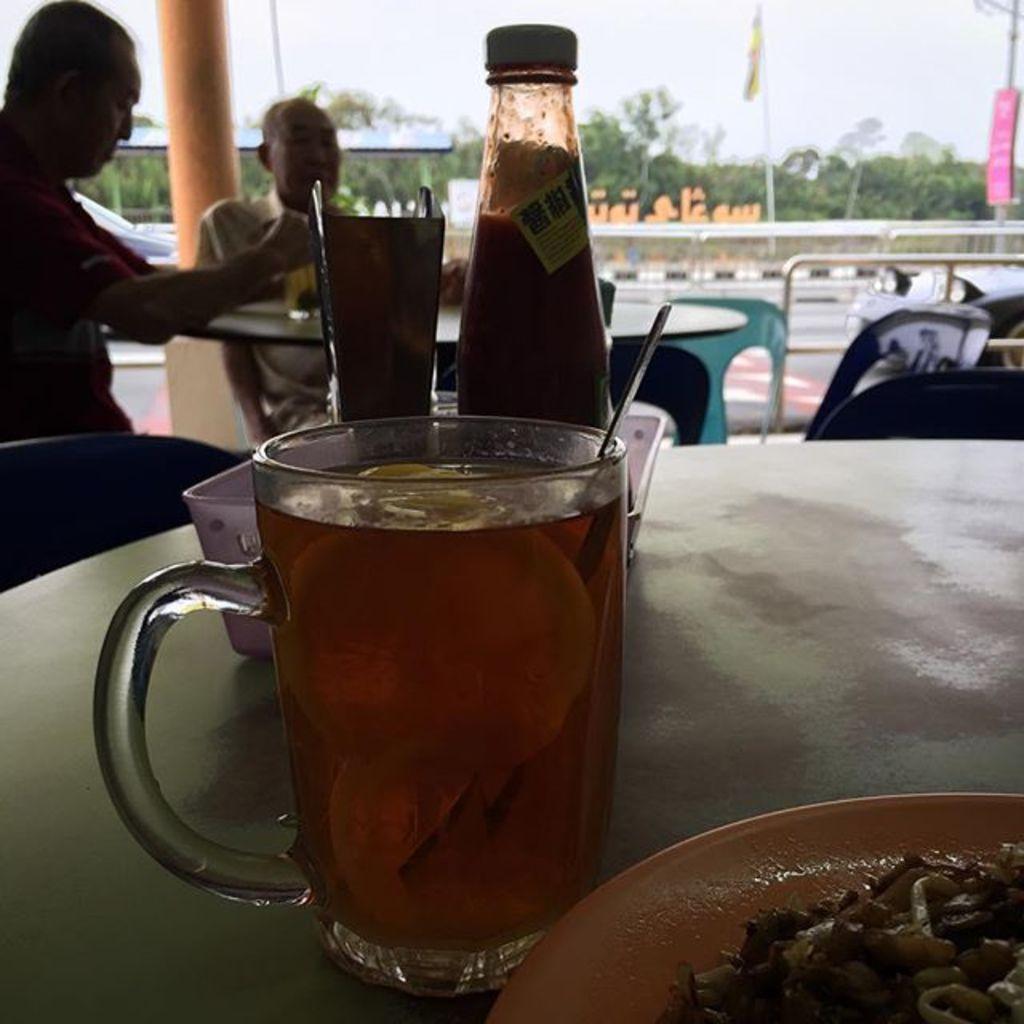Describe this image in one or two sentences. In this image there is a table having a mug, tray and a plate on it. Try is having a bottle and an object on it. Mug is filled with some drink in it. Plate is having some food on it. Behind the table there are few chairs. Two persons are sitting on the chair before a table having a glass on it. There is a road, beside there are flags attached to the poles which are on the pavement. There are few trees. Top of image there is sky. 